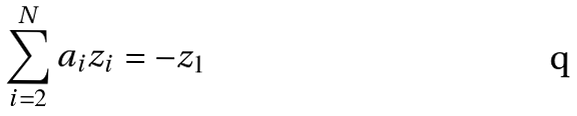<formula> <loc_0><loc_0><loc_500><loc_500>\sum _ { i = 2 } ^ { N } a _ { i } z _ { i } = - z _ { 1 }</formula> 